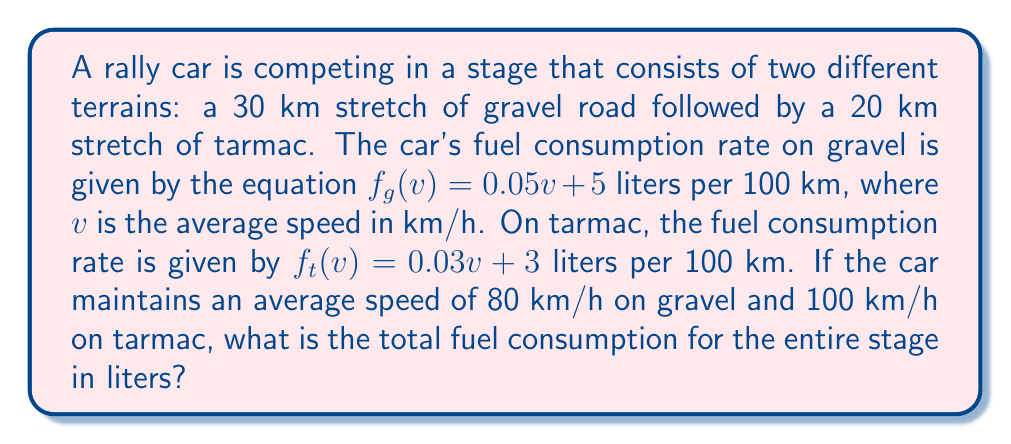Can you answer this question? Let's break this down step-by-step:

1. Calculate the fuel consumption rate for the gravel section:
   $f_g(80) = 0.05(80) + 5 = 9$ liters per 100 km

2. Calculate the fuel consumption rate for the tarmac section:
   $f_t(100) = 0.03(100) + 3 = 6$ liters per 100 km

3. Calculate the fuel consumed on the gravel section:
   Gravel distance = 30 km
   Fuel consumed = $9 \times \frac{30}{100} = 2.7$ liters

4. Calculate the fuel consumed on the tarmac section:
   Tarmac distance = 20 km
   Fuel consumed = $6 \times \frac{20}{100} = 1.2$ liters

5. Sum up the total fuel consumption:
   Total fuel = Gravel fuel + Tarmac fuel
              = $2.7 + 1.2 = 3.9$ liters

Therefore, the total fuel consumption for the entire stage is 3.9 liters.
Answer: 3.9 liters 